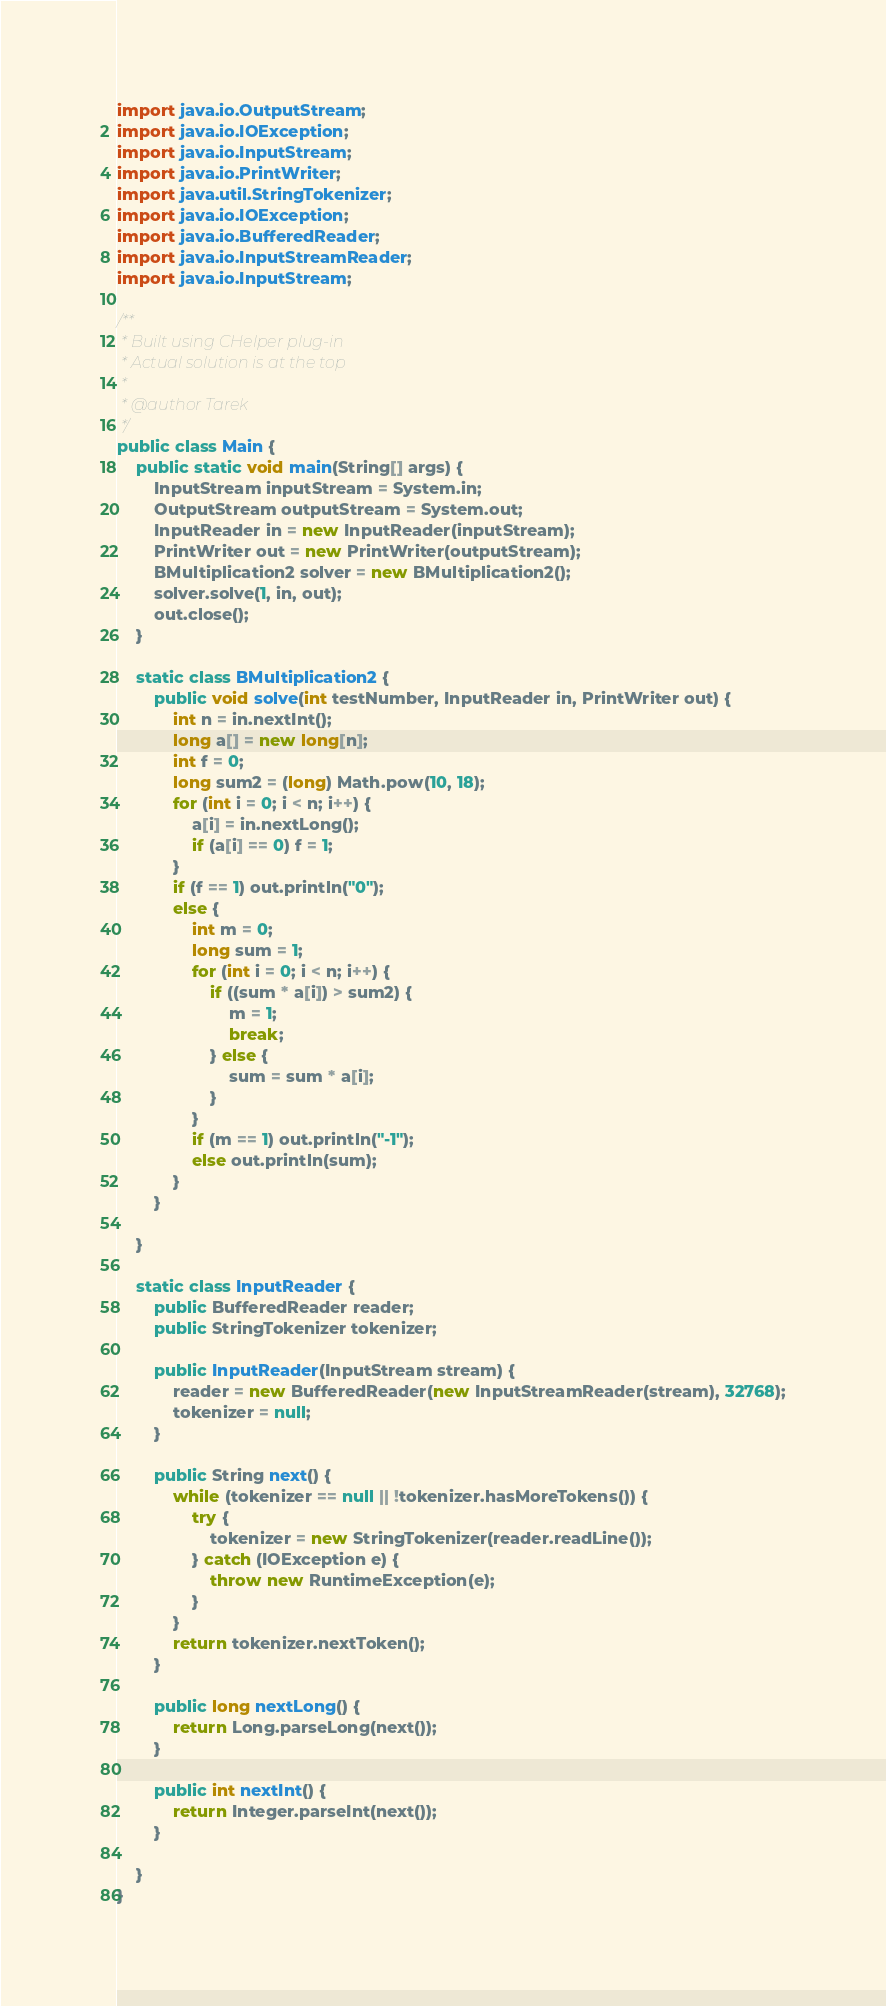<code> <loc_0><loc_0><loc_500><loc_500><_Java_>import java.io.OutputStream;
import java.io.IOException;
import java.io.InputStream;
import java.io.PrintWriter;
import java.util.StringTokenizer;
import java.io.IOException;
import java.io.BufferedReader;
import java.io.InputStreamReader;
import java.io.InputStream;

/**
 * Built using CHelper plug-in
 * Actual solution is at the top
 *
 * @author Tarek
 */
public class Main {
    public static void main(String[] args) {
        InputStream inputStream = System.in;
        OutputStream outputStream = System.out;
        InputReader in = new InputReader(inputStream);
        PrintWriter out = new PrintWriter(outputStream);
        BMultiplication2 solver = new BMultiplication2();
        solver.solve(1, in, out);
        out.close();
    }

    static class BMultiplication2 {
        public void solve(int testNumber, InputReader in, PrintWriter out) {
            int n = in.nextInt();
            long a[] = new long[n];
            int f = 0;
            long sum2 = (long) Math.pow(10, 18);
            for (int i = 0; i < n; i++) {
                a[i] = in.nextLong();
                if (a[i] == 0) f = 1;
            }
            if (f == 1) out.println("0");
            else {
                int m = 0;
                long sum = 1;
                for (int i = 0; i < n; i++) {
                    if ((sum * a[i]) > sum2) {
                        m = 1;
                        break;
                    } else {
                        sum = sum * a[i];
                    }
                }
                if (m == 1) out.println("-1");
                else out.println(sum);
            }
        }

    }

    static class InputReader {
        public BufferedReader reader;
        public StringTokenizer tokenizer;

        public InputReader(InputStream stream) {
            reader = new BufferedReader(new InputStreamReader(stream), 32768);
            tokenizer = null;
        }

        public String next() {
            while (tokenizer == null || !tokenizer.hasMoreTokens()) {
                try {
                    tokenizer = new StringTokenizer(reader.readLine());
                } catch (IOException e) {
                    throw new RuntimeException(e);
                }
            }
            return tokenizer.nextToken();
        }

        public long nextLong() {
            return Long.parseLong(next());
        }

        public int nextInt() {
            return Integer.parseInt(next());
        }

    }
}

</code> 